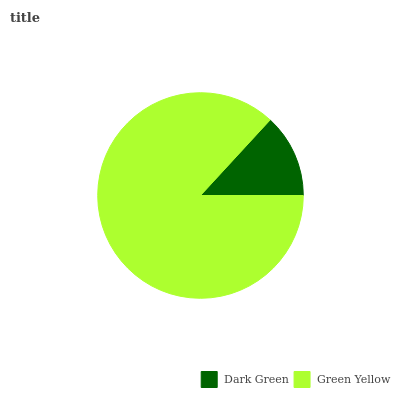Is Dark Green the minimum?
Answer yes or no. Yes. Is Green Yellow the maximum?
Answer yes or no. Yes. Is Green Yellow the minimum?
Answer yes or no. No. Is Green Yellow greater than Dark Green?
Answer yes or no. Yes. Is Dark Green less than Green Yellow?
Answer yes or no. Yes. Is Dark Green greater than Green Yellow?
Answer yes or no. No. Is Green Yellow less than Dark Green?
Answer yes or no. No. Is Green Yellow the high median?
Answer yes or no. Yes. Is Dark Green the low median?
Answer yes or no. Yes. Is Dark Green the high median?
Answer yes or no. No. Is Green Yellow the low median?
Answer yes or no. No. 